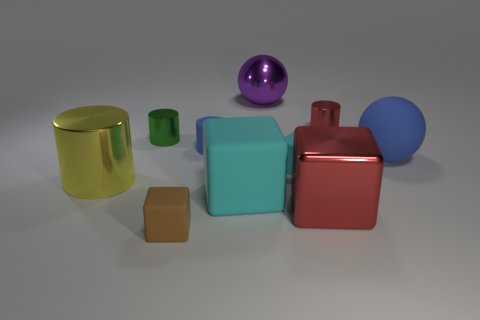Subtract all spheres. How many objects are left? 8 Add 8 big purple shiny balls. How many big purple shiny balls are left? 9 Add 8 blue rubber objects. How many blue rubber objects exist? 10 Subtract 0 red spheres. How many objects are left? 10 Subtract all large cylinders. Subtract all big yellow shiny cylinders. How many objects are left? 8 